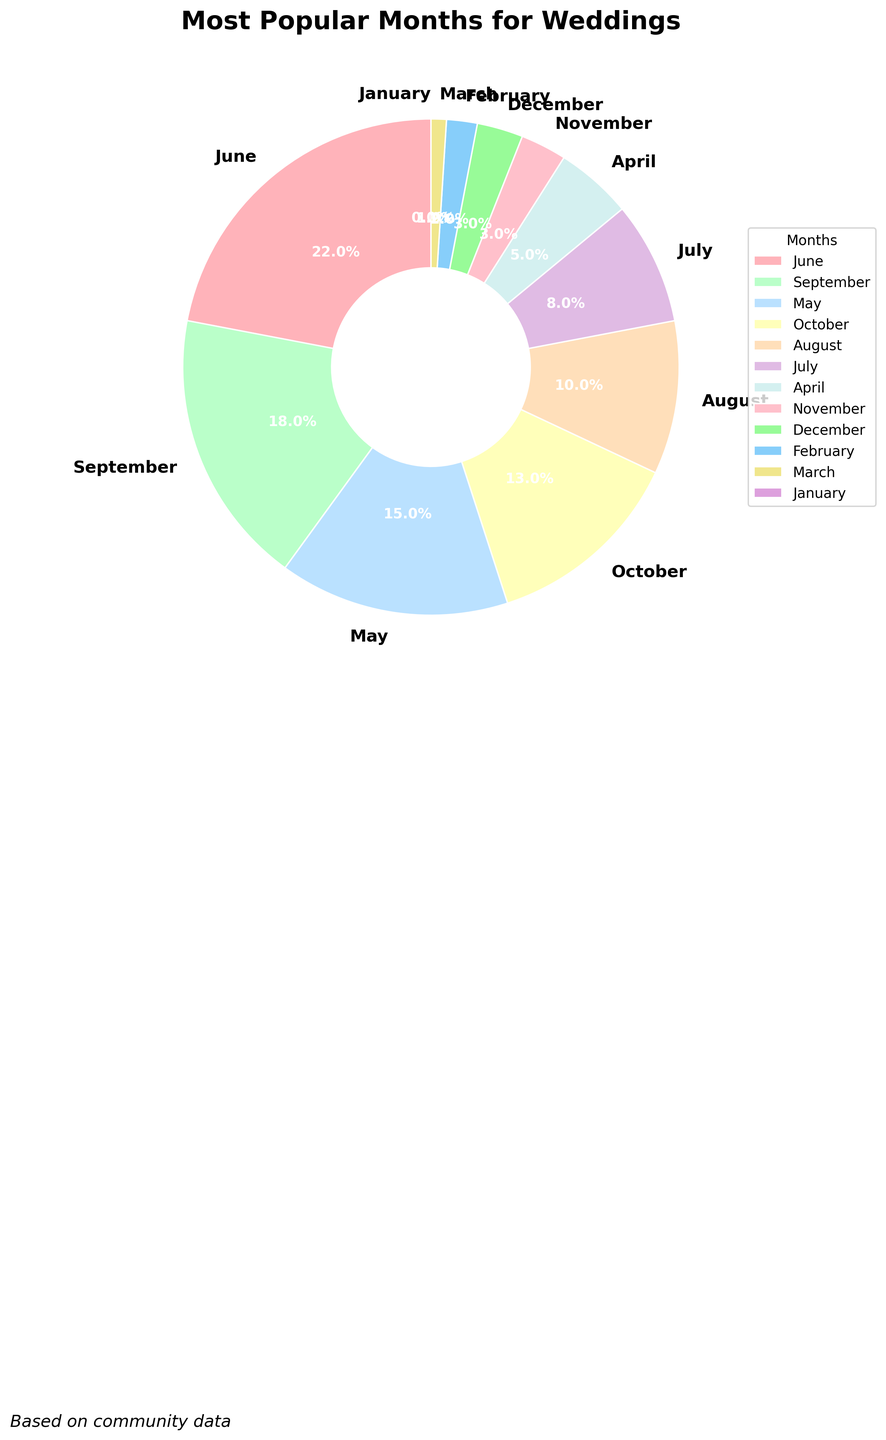What is the most popular month for weddings? Looking at the pie chart, we find June has the largest slice, occupying 22% of the total.
Answer: June Which months have the same percentage of weddings? From the pie chart, both November and December have 3%, indicating they have the same popularity.
Answer: November, December What is the combined percentage of weddings in September and October? Adding the percentages for September (18%) and October (13%) gives us 18 + 13 = 31%.
Answer: 31% Which month has the least number of weddings? The smallest slice on the pie chart represents January, which is labeled with 0%.
Answer: January Which is more popular for weddings, August or July, and by how much? August has 10% while July has 8%; the difference is 10 - 8 = 2%.
Answer: August by 2% What is the gap between the most and least popular wedding months? The most popular month, June, has 22%, and the least popular month, January, has 0%; thus, the gap is 22 - 0 = 22%.
Answer: 22% What's the average percentage of weddings for the months making up the top three? Summing the top three percentages: June (22%) + September (18%) + May (15%) = 55%. The average is 55 / 3 ≈ 18.33%.
Answer: 18.33% How many months account for less than 10% of weddings? From the pie chart, the months below 10% are July (8%), April (5%), November (3%), December (3%), February (2%), March (1%), and January (0%), making a total of 7 months.
Answer: 7 What is the combined percentage of weddings from April to November? Summing the percentages from April (5%), May (15%), June (22%), July (8%), August (10%), September (18%), October (13%), and November (3%) results in 94%.
Answer: 94% Which months have percentages within 5% of each other, and what are they? Observing the pie chart, July (8%) and August (10%) differ by 2%, April (5%) and November/December (3%) differ by 2%, and September (18%) and May (15%) differ by 3%.
Answer: July, August; April, November, December; September, May 